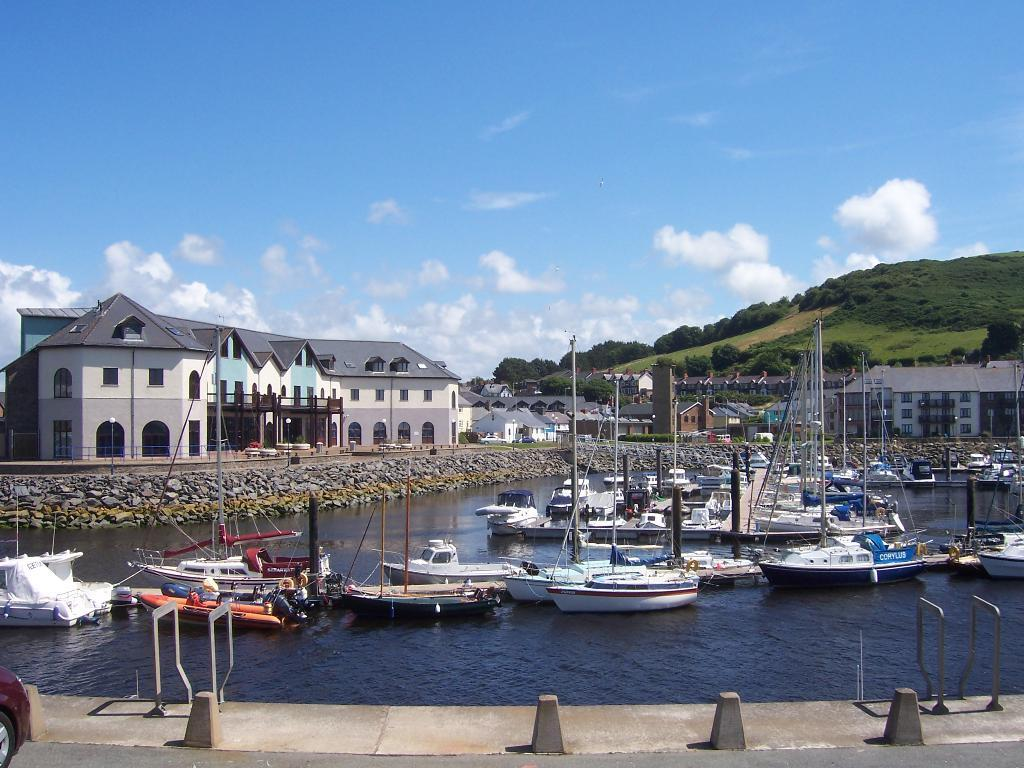What type of structures can be seen in the image? There are buildings in the image. What can be seen in the water in the image? There are boats in the water in the image. What is the mountain in the image covered with? The mountain in the image is covered with grass and trees. What type of barrier is present in the image? There is a fence in the image. What is visible in the sky in the image? There are clouds in the sky in the image. What type of lamp is hanging from the tree in the image? There is no lamp present in the image; it features buildings, boats, a mountain, a fence, and clouds. What type of jeans are the people wearing in the image? There are no people visible in the image, so it is impossible to determine what type of jeans they might be wearing. 